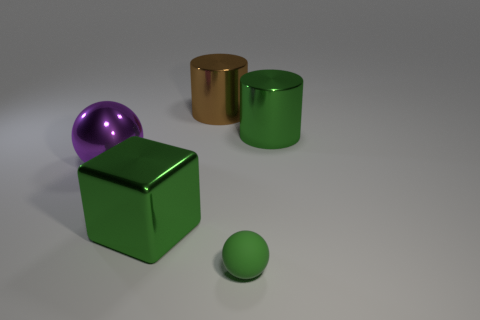Does the big green thing on the right side of the large brown cylinder have the same material as the small green sphere that is in front of the brown metal cylinder? While the big green cube and the small green sphere share a similar color, they do not have the same material finish. The cube appears to have a more matte, solid finish, whereas the sphere has a glossy, perhaps more plasticky finish. This difference in sheen indicates that they're made from different materials or treated differently during manufacturing. 